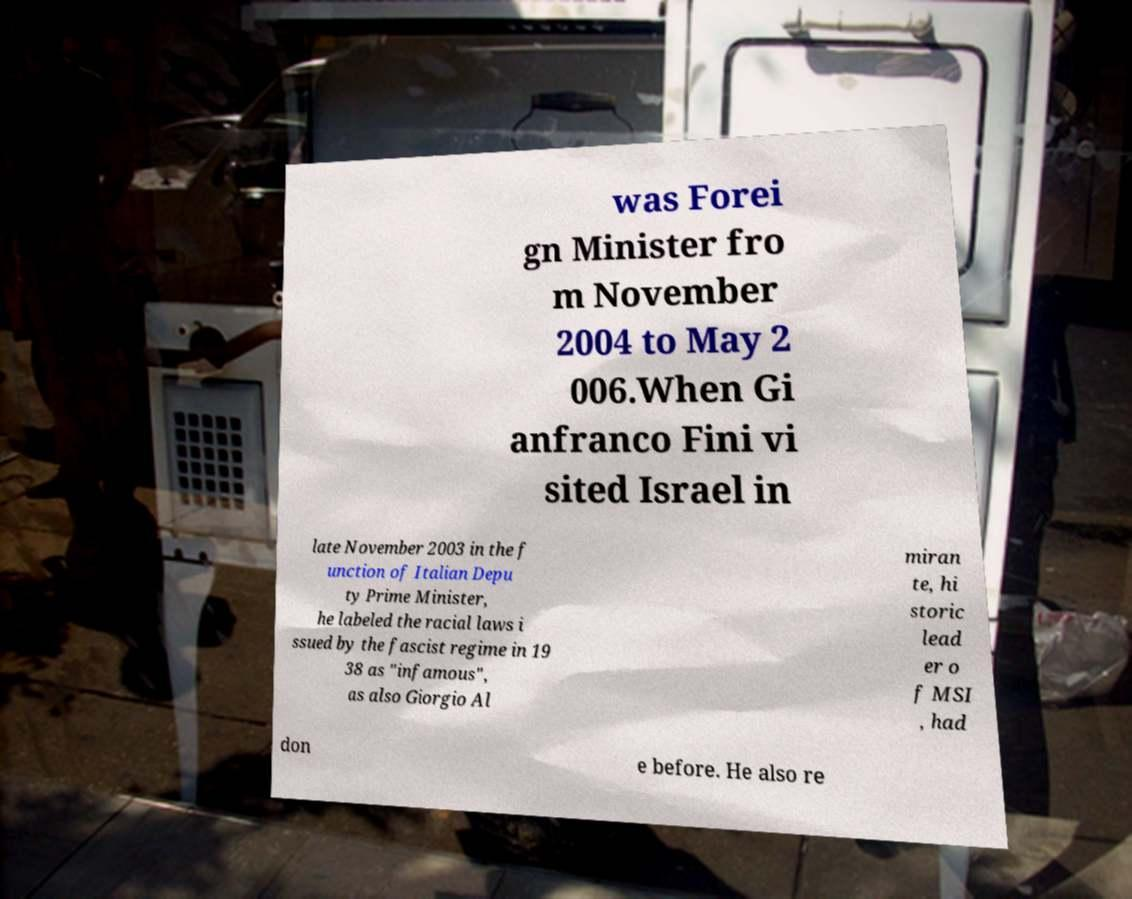Please read and relay the text visible in this image. What does it say? was Forei gn Minister fro m November 2004 to May 2 006.When Gi anfranco Fini vi sited Israel in late November 2003 in the f unction of Italian Depu ty Prime Minister, he labeled the racial laws i ssued by the fascist regime in 19 38 as "infamous", as also Giorgio Al miran te, hi storic lead er o f MSI , had don e before. He also re 